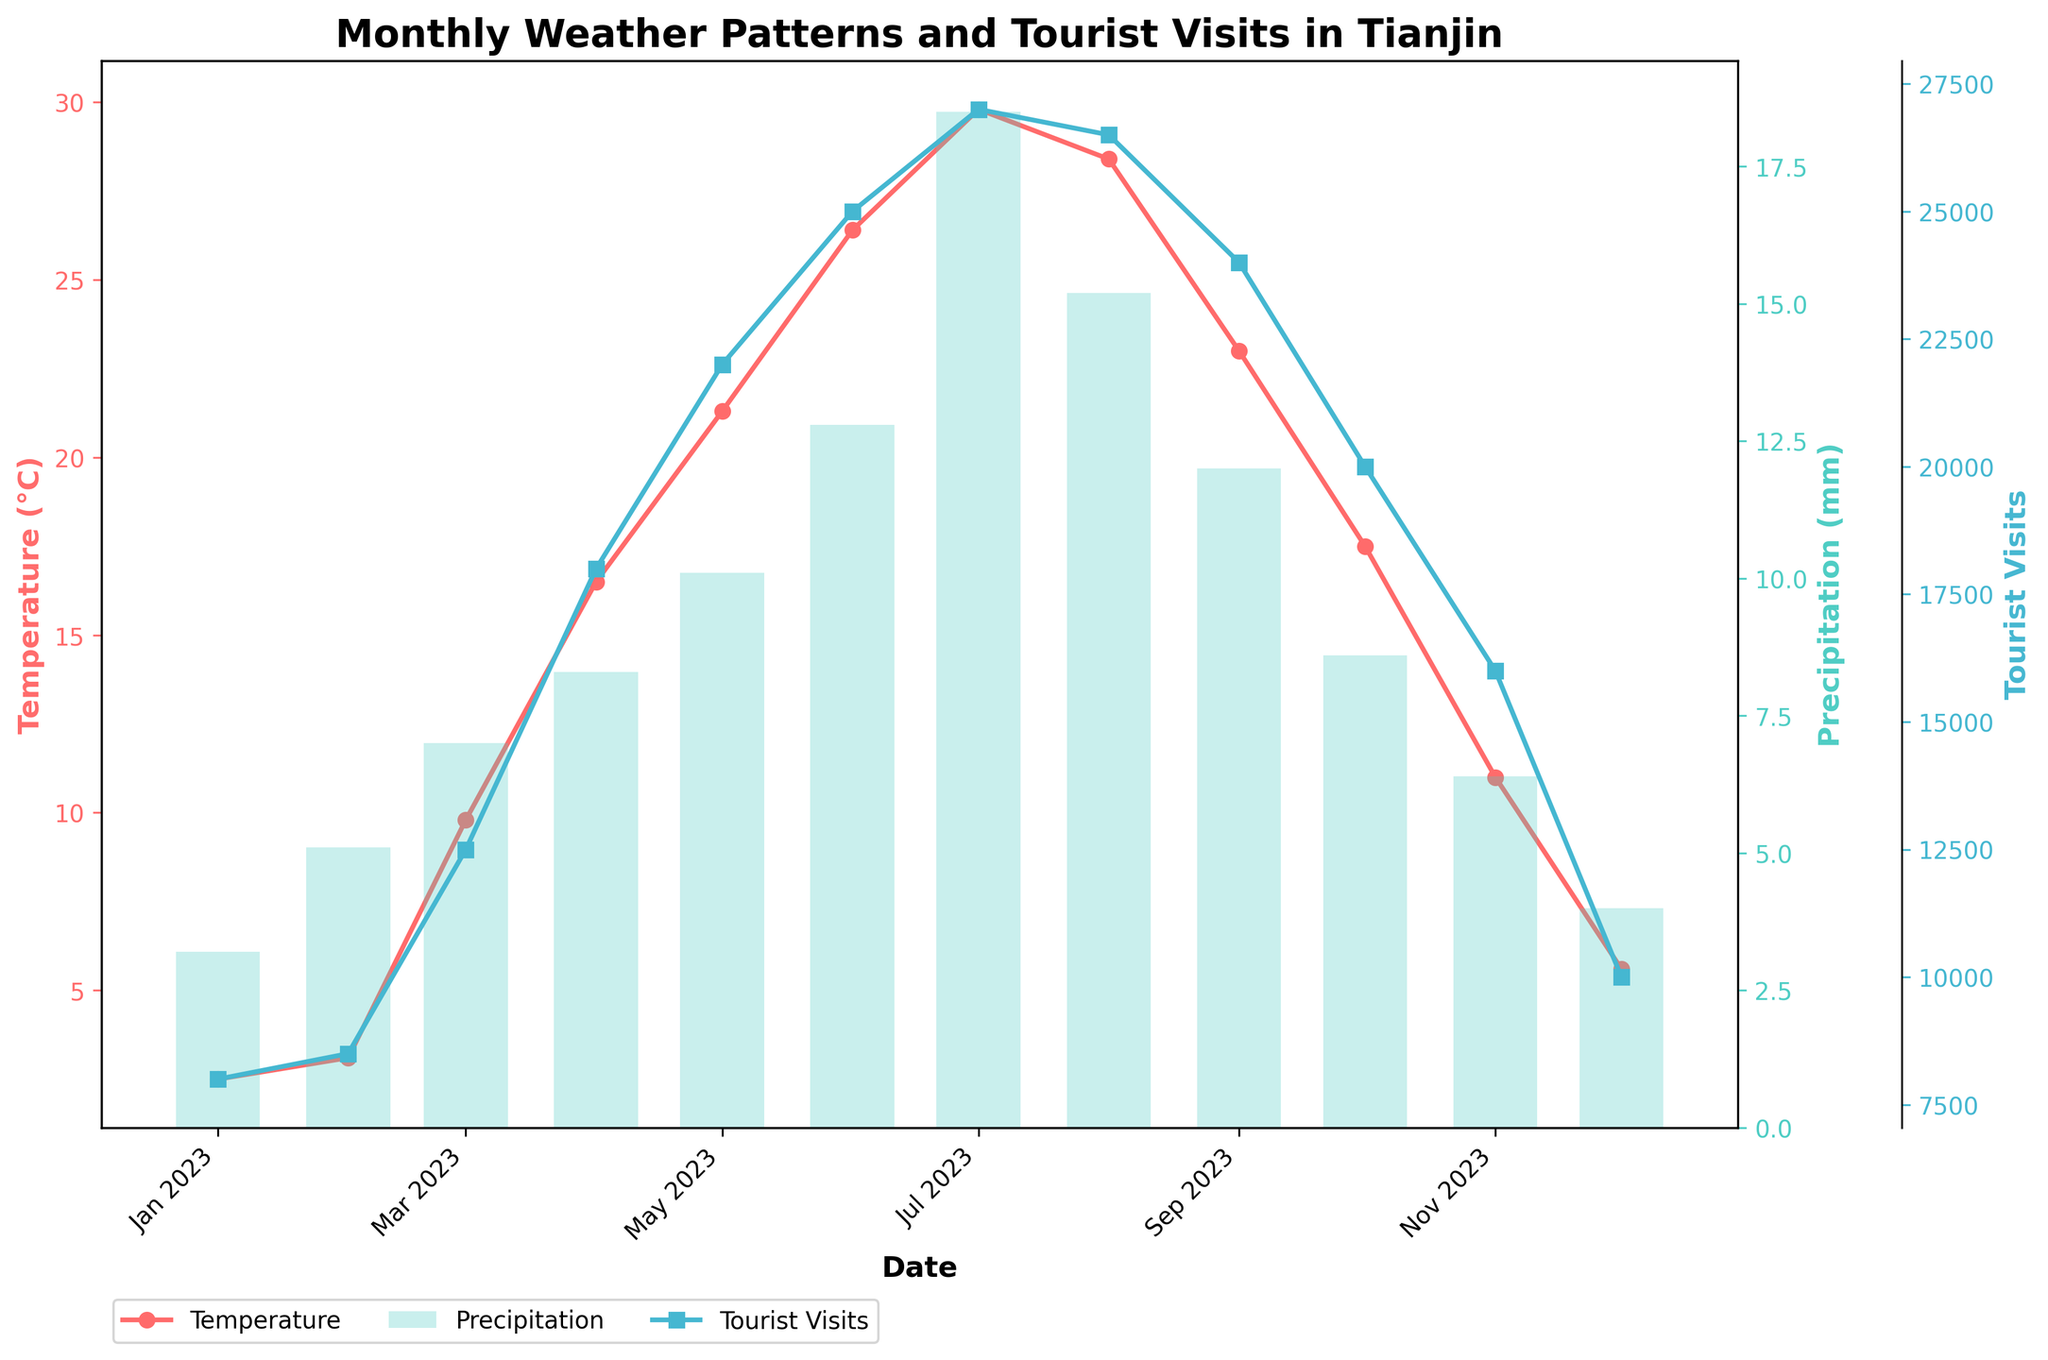What is the title of the plot? The title is usually located at the top of the plot, and in this case, it reads "Monthly Weather Patterns and Tourist Visits in Tianjin".
Answer: Monthly Weather Patterns and Tourist Visits in Tianjin How many data points are shown for each line or bar in the plot? Inspect the x-axis for the number of unique dates. Each date represents a data point. There are 12 dates representing each month from January to December.
Answer: 12 What is the temperature in Celsius for July 2023? Locate the point on the temperature line (red line with markers) corresponding to July 2023 on the x-axis. Read the precise value on the y-axis associated with the temperature.
Answer: 29.8°C Which month had the highest number of tourist visits? Observe the tourist visits line (blue line with markers) and identify the peak point. The highest value is in July 2023 with 27,000 visitors.
Answer: July What is the difference in tourist visits between the months with the highest and lowest temperatures? Identify the months with the highest (July) and lowest (January) temperatures. Read their tourist visit values from the plot: July has 27,000 and January has 8,000. The difference is 27,000 - 8,000 = 19,000.
Answer: 19,000 How does the precipitation in October compare to that in May? Compare the height of the bars for October and May. October's precipitation is shown as 8.6 mm, and May's is 10.1 mm, indicating that October has less precipitation.
Answer: October is less Which months show an increase in tourist visits compared to the previous month? Track the changes in the tourist visits line graph. Observe where the markers indicate a rise from one month to the next: February to March, March to April, April to May, May to June, and June to July.
Answer: February to March, March to April, April to May, May to June, June to July Is there a month where tourist visits decline, but the temperature is increasing? Examine the tourist visits and temperature lines simultaneously. Check for any month where the visits decrease while the temperature increases. For instance, August shows fewer visits than July, while the temperature remains constant.
Answer: August What is the average temperature over the 12 months? Summarize all the temperature values for each month, then divide by the number of months. Calculation: (2.5 + 3.1 + 9.8 + 16.5 + 21.3 + 26.4 + 29.8 + 28.4 + 23.0 + 17.5 + 11.0 + 5.6) / 12. The result is approximately 16.1°C.
Answer: 16.1°C Which month has the greatest difference between temperature and precipitation? Calculate the difference for each month by subtracting the precipitation value from the temperature. Identify the month with the largest value: July has the largest difference (29.8 - 18.5 = 11.3).
Answer: July 